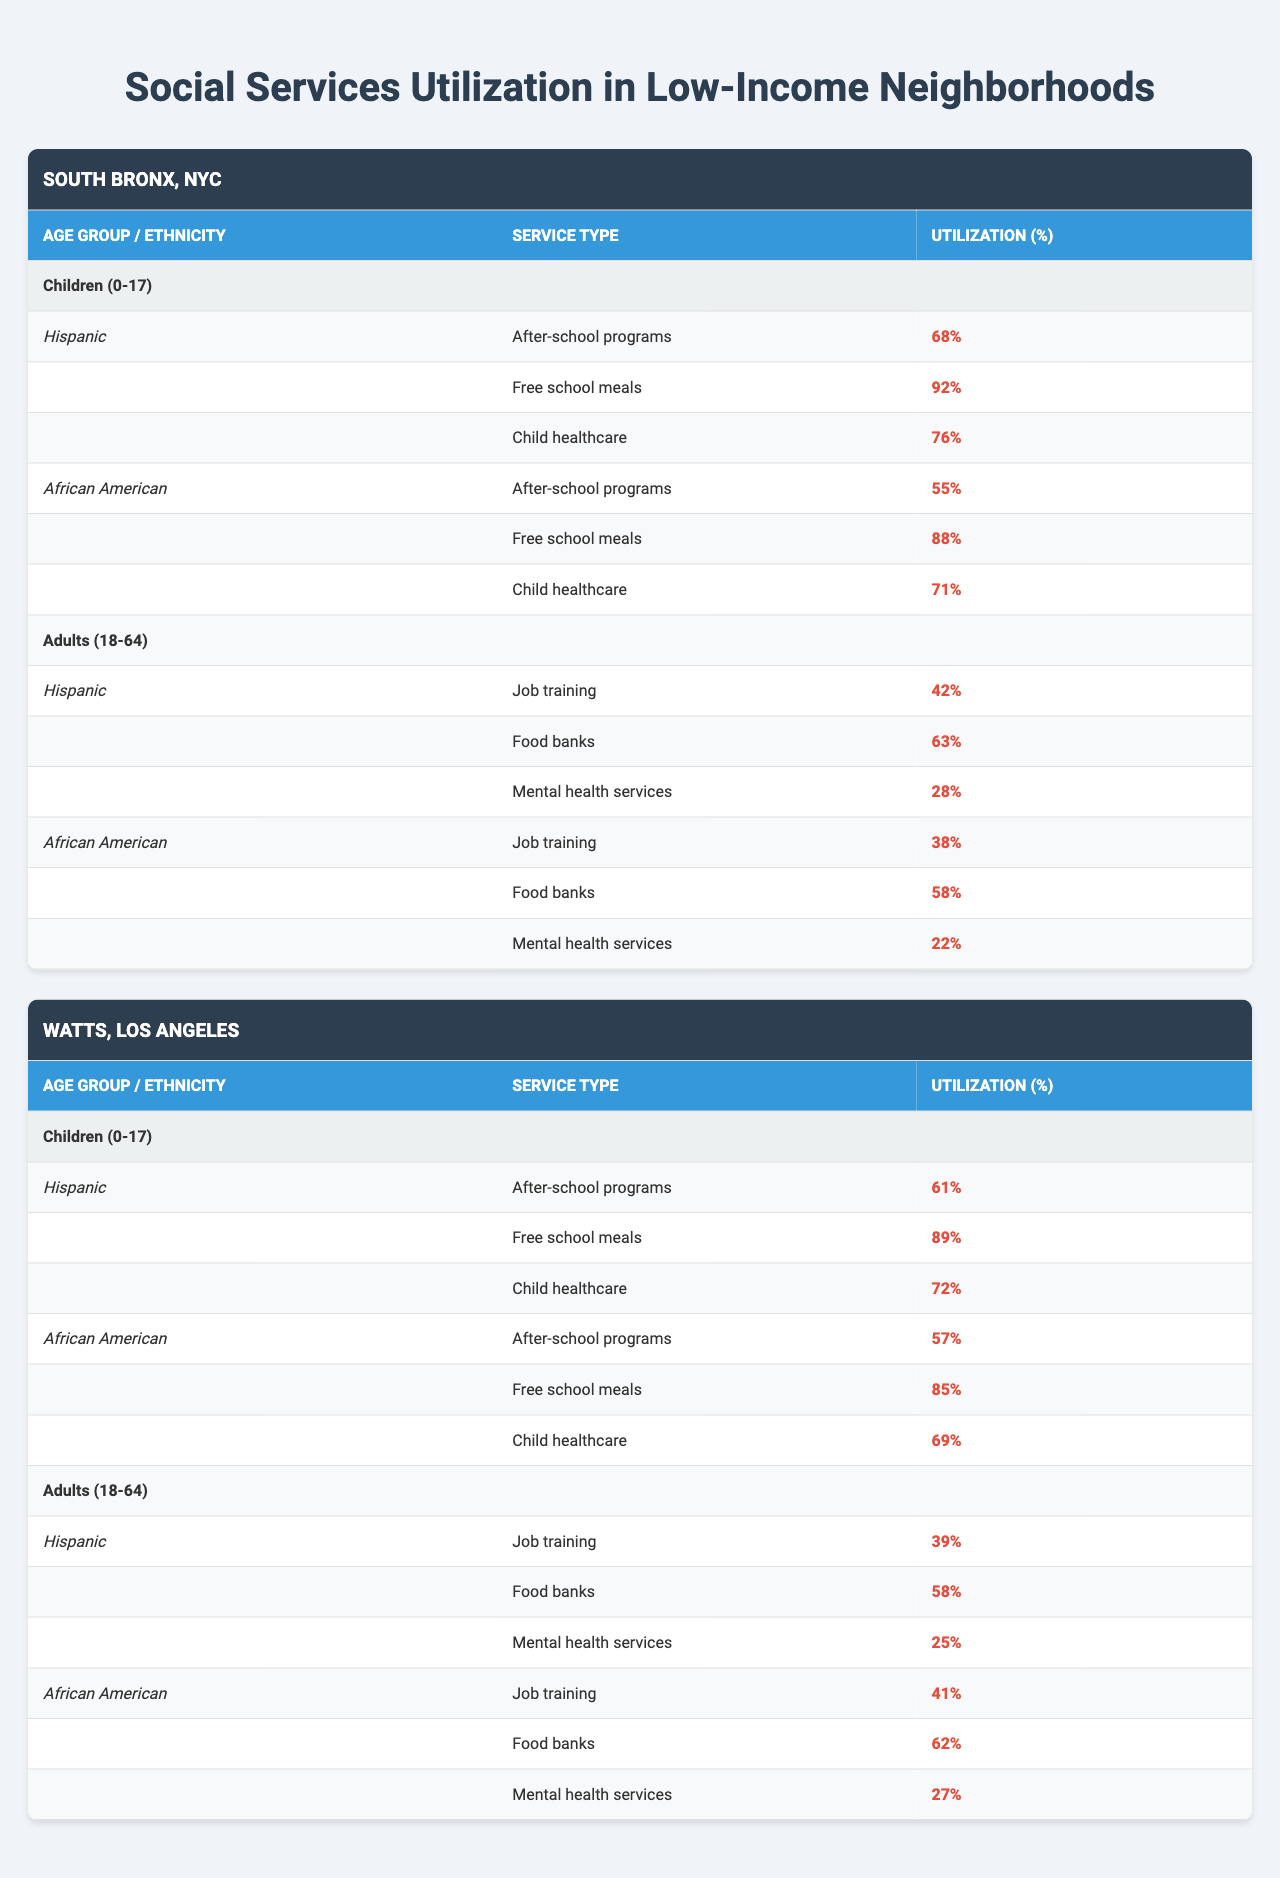What is the utilization percentage of free school meals for Hispanic children in the South Bronx? The table shows that for Hispanic children (0-17 years) in the South Bronx, the utilization percentage of free school meals is 92%.
Answer: 92% Which neighborhood has higher utilization for after-school programs among African American children? In the table, after-school program utilization is 55% for African American children in the South Bronx and 57% in Watts. Therefore, Watts has higher utilization.
Answer: Watts What is the utilization difference for job training services between Hispanic adults in South Bronx and Watts? Hispanic adults in the South Bronx have a job training utilization of 42%, while in Watts, it is 39%. The difference is calculated as 42% - 39% = 3%.
Answer: 3% Are Hispanic adults more likely to utilize mental health services than African American adults in either neighborhood? In the South Bronx, Hispanic adults have a utilization of 28% for mental health services, while African American adults have 22%. In Watts, Hispanic adults have 25% usage, and African American adults have 27%. Therefore, in the South Bronx, Hispanic adults utilize more, but in Watts, African American adults do.
Answer: No What is the average utilization percentage of free school meals for children across both neighborhoods? The utilization percentages for free school meals are 92% in the South Bronx (Hispanic), 88% (African American), 89% (Hispanic) in Watts, and 85% (African American). Summing these gives 92 + 88 + 89 + 85 = 354%. There are 4 data points, so the average is 354% / 4 = 88.5%.
Answer: 88.5% Which service has the lowest utilization percentage for Hispanic adults in both neighborhoods? The table indicates that the mental health services have the lowest utilization percentage for Hispanic adults in both neighborhoods: 28% in South Bronx and 25% in Watts.
Answer: 25% How do the utilizations of food banks compare between Hispanic and African American adults in Watts? In Watts, the utilization for food banks is 58% for Hispanic adults and 62% for African American adults. African American adults utilize food banks more than Hispanic adults in Watts.
Answer: African American adults utilize more What is the total utilization percentage for child healthcare services in the South Bronx? For children in the South Bronx, the utilization percentage for child healthcare is 76% for Hispanic and 71% for African American. The total is 76 + 71 = 147%.
Answer: 147% 